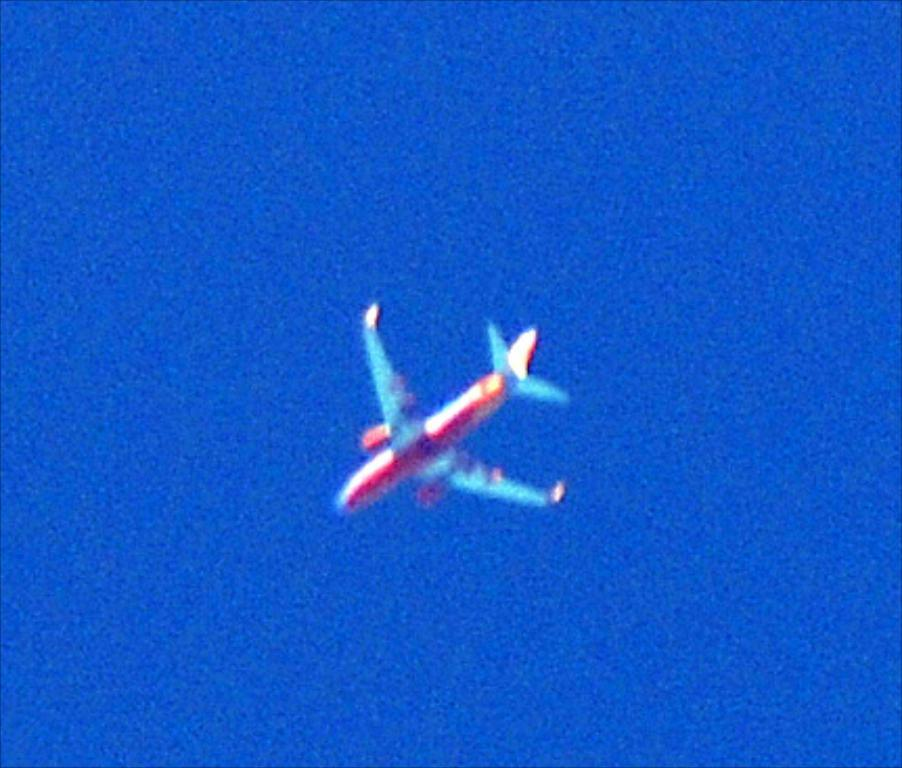What is the main subject of the image? The main subject of the image is an aircraft. Can you describe the appearance of the aircraft? The aircraft is colorful. What color is the background of the image? The background of the image is blue. What type of steel is used to construct the tank in the image? There is no tank present in the image, and therefore no steel construction can be observed. What message of hope can be seen in the image? There is no message of hope depicted in the image; it features an aircraft with a blue background. 